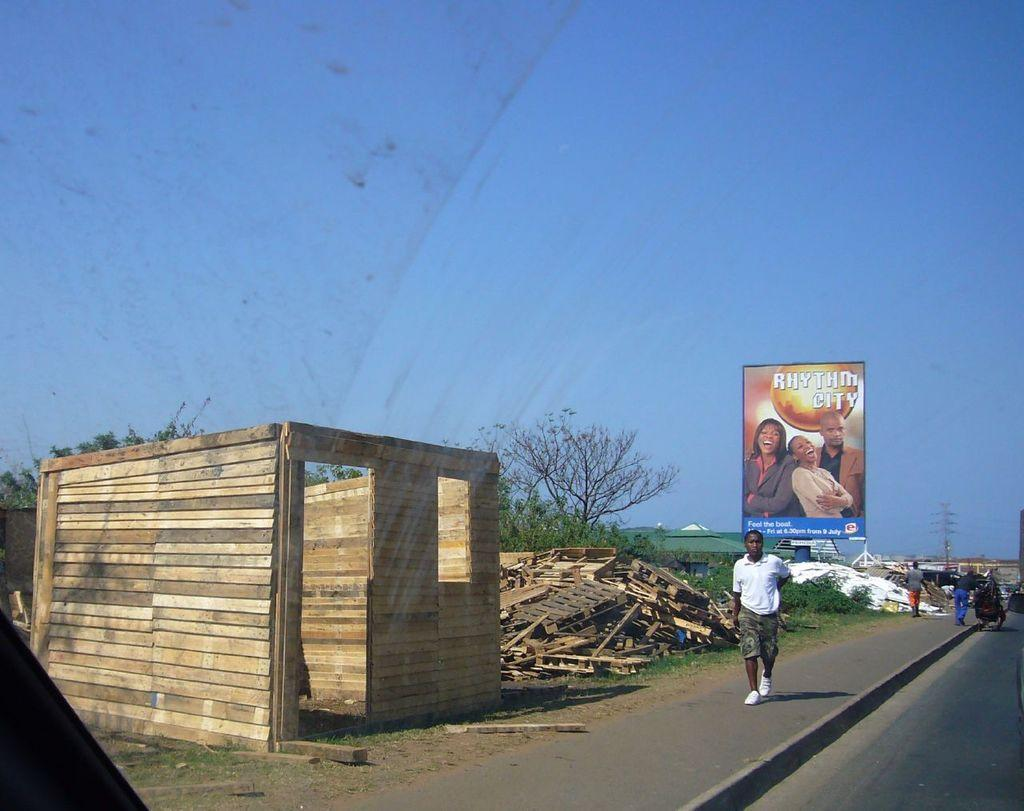<image>
Describe the image concisely. A man is walking down the road with a partially completed shed off to the side of the road and the cover of Rhythm City floating in the sky. 